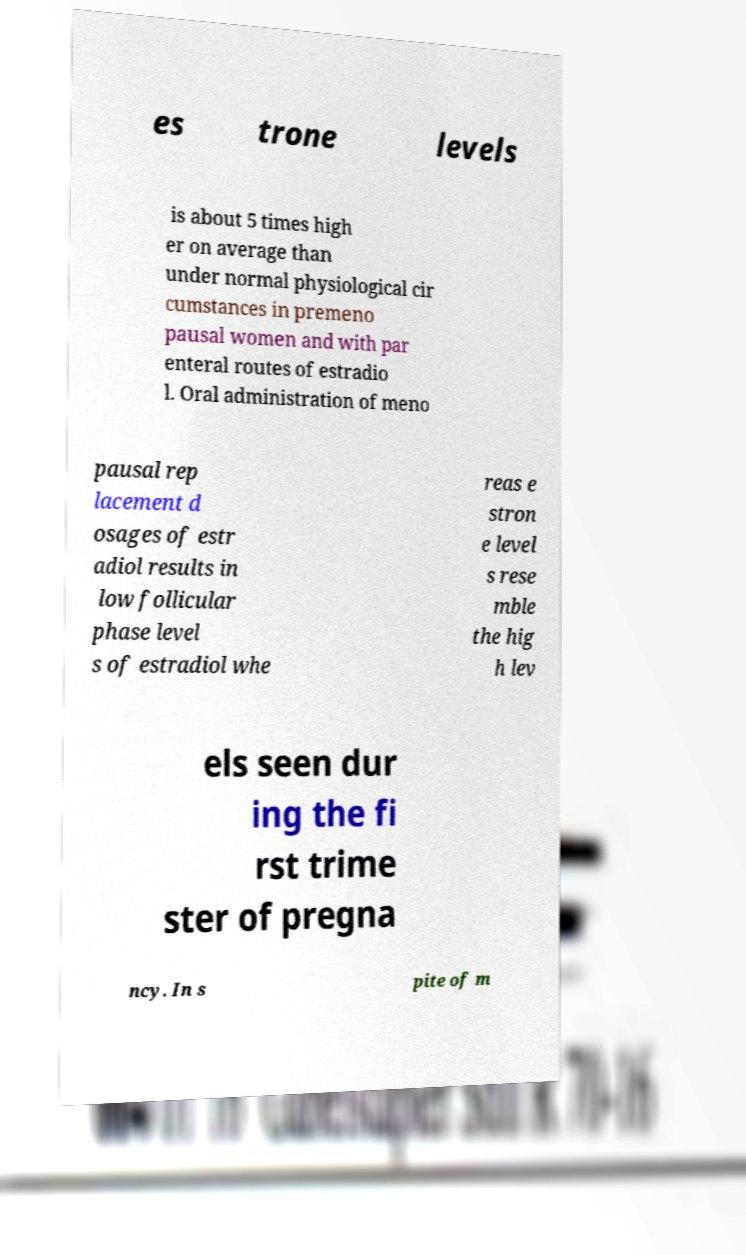Could you assist in decoding the text presented in this image and type it out clearly? es trone levels is about 5 times high er on average than under normal physiological cir cumstances in premeno pausal women and with par enteral routes of estradio l. Oral administration of meno pausal rep lacement d osages of estr adiol results in low follicular phase level s of estradiol whe reas e stron e level s rese mble the hig h lev els seen dur ing the fi rst trime ster of pregna ncy. In s pite of m 